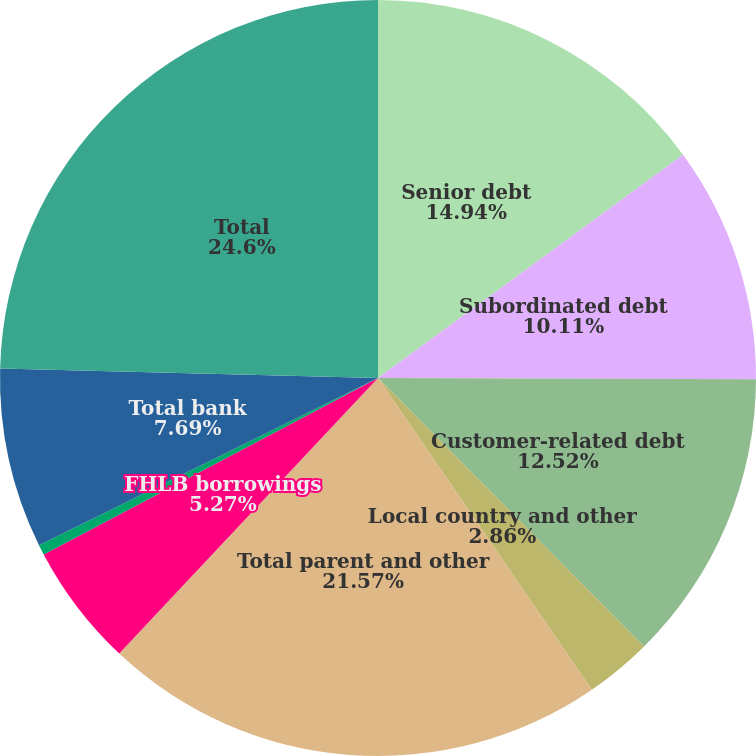Convert chart. <chart><loc_0><loc_0><loc_500><loc_500><pie_chart><fcel>Senior debt<fcel>Subordinated debt<fcel>Customer-related debt<fcel>Local country and other<fcel>Total parent and other<fcel>FHLB borrowings<fcel>Securitizations<fcel>Total bank<fcel>Total<nl><fcel>14.94%<fcel>10.11%<fcel>12.52%<fcel>2.86%<fcel>21.57%<fcel>5.27%<fcel>0.44%<fcel>7.69%<fcel>24.6%<nl></chart> 